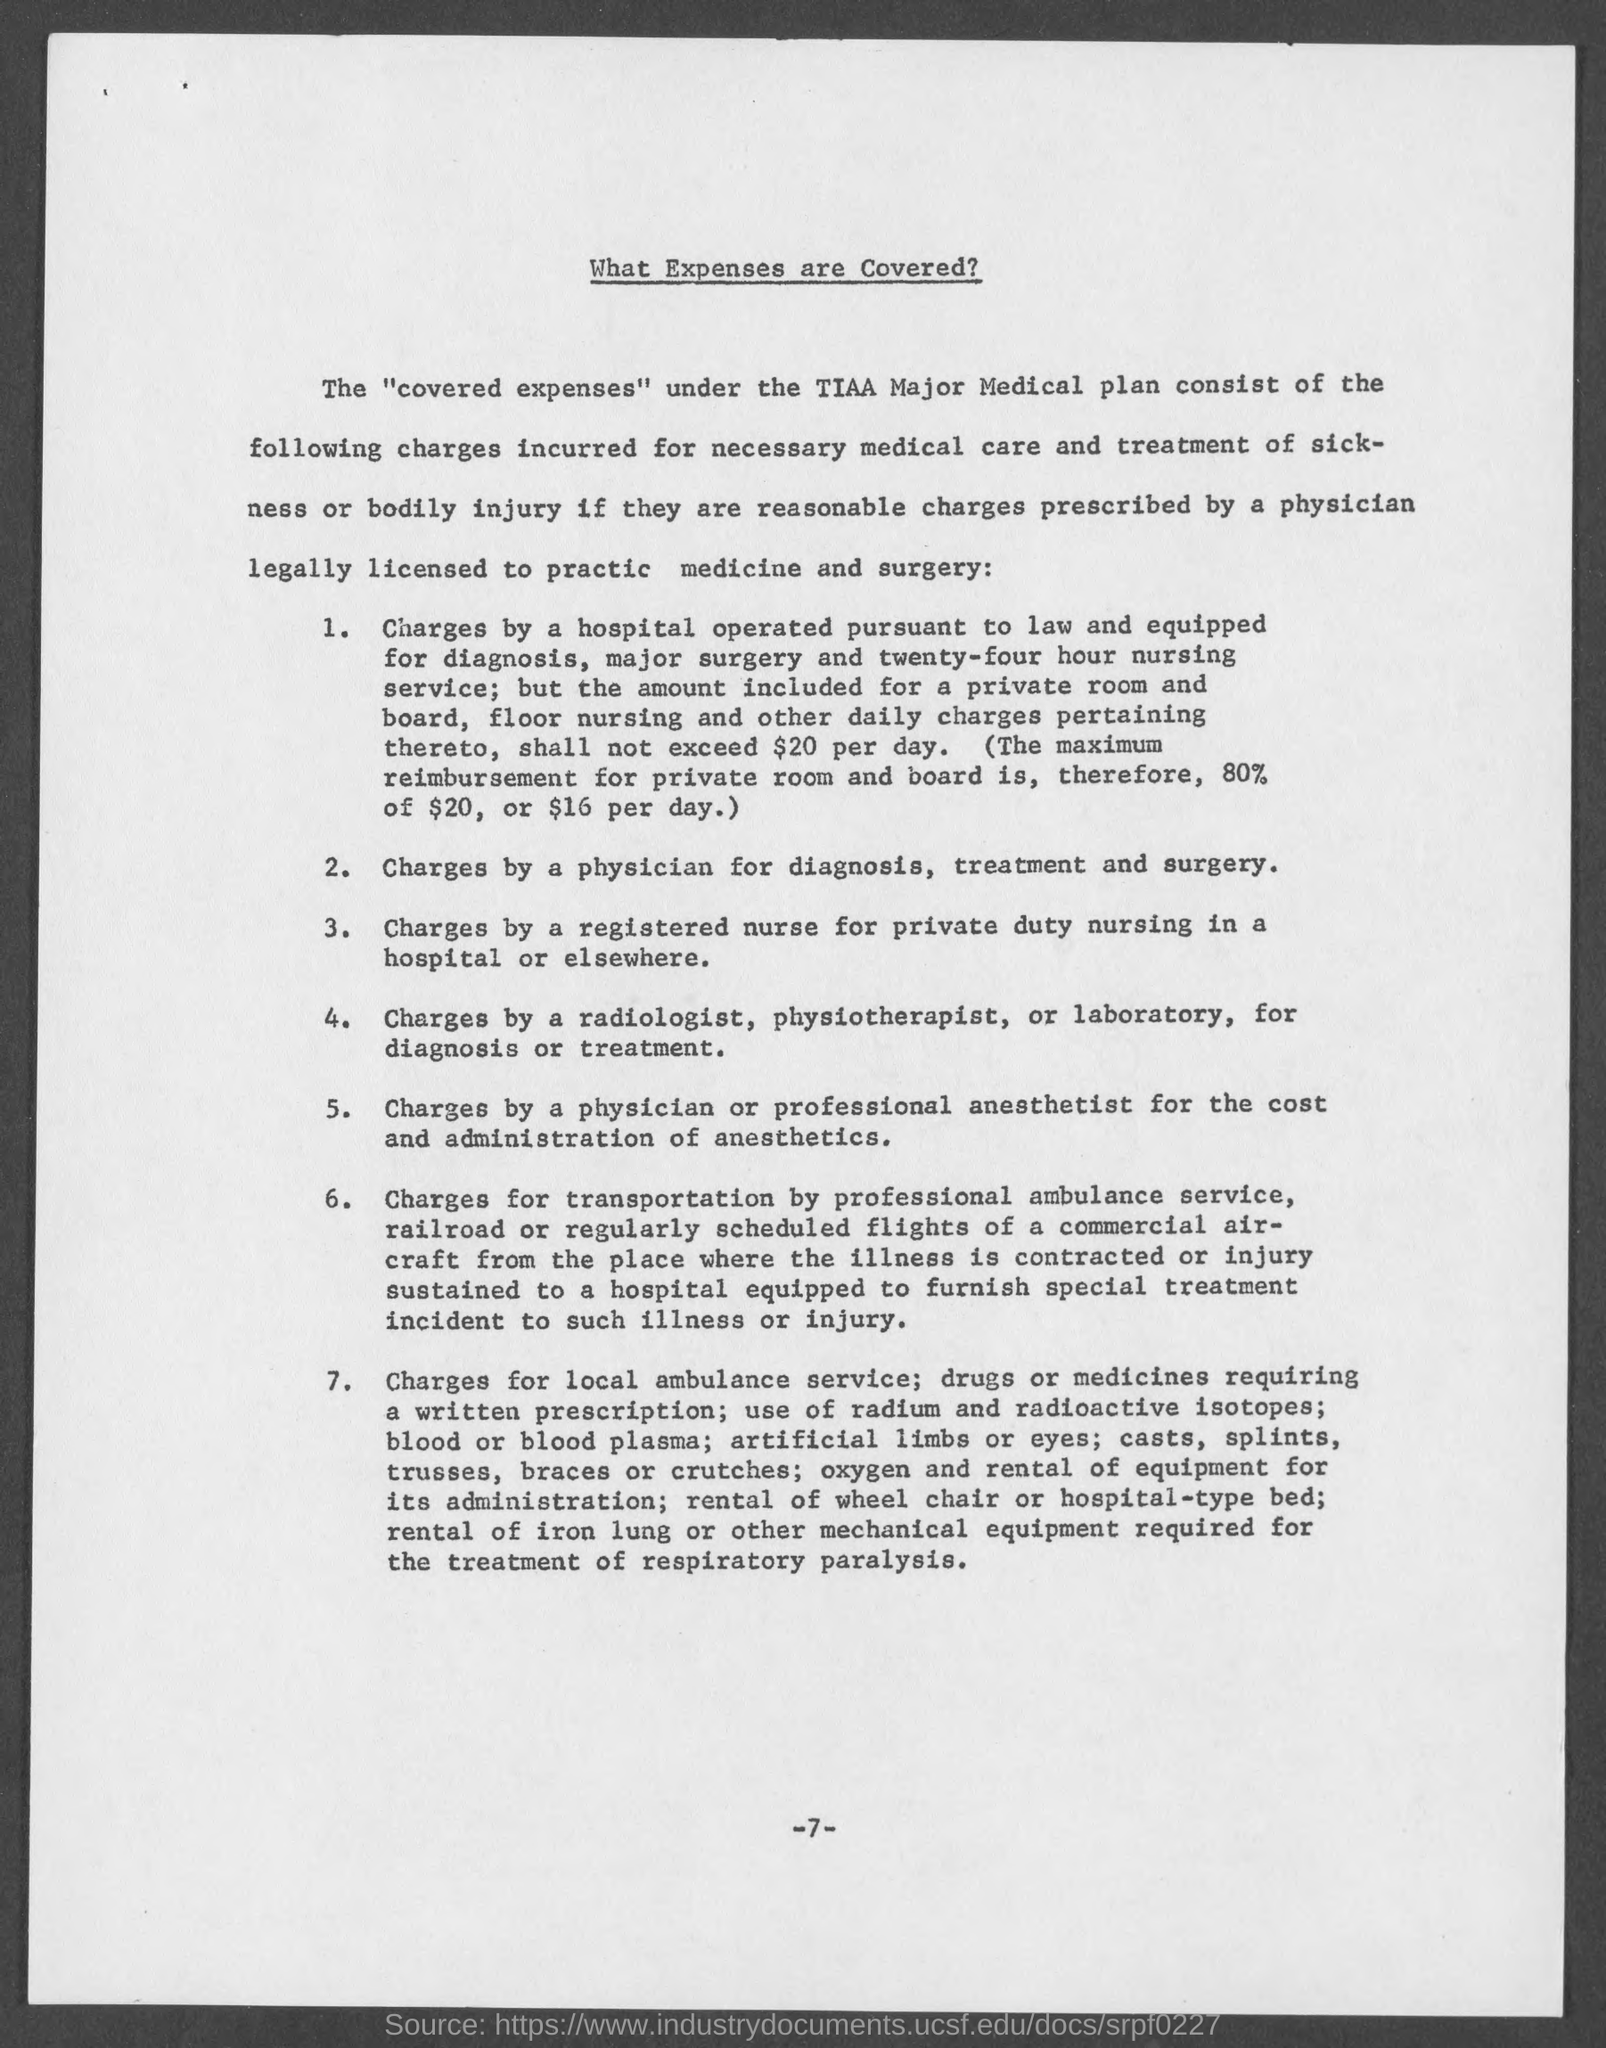Specify some key components in this picture. The title of the page is [insert title], and it provides information on the expenses that are covered [insert information on coverage]. The page number at the bottom of the page is 7. 